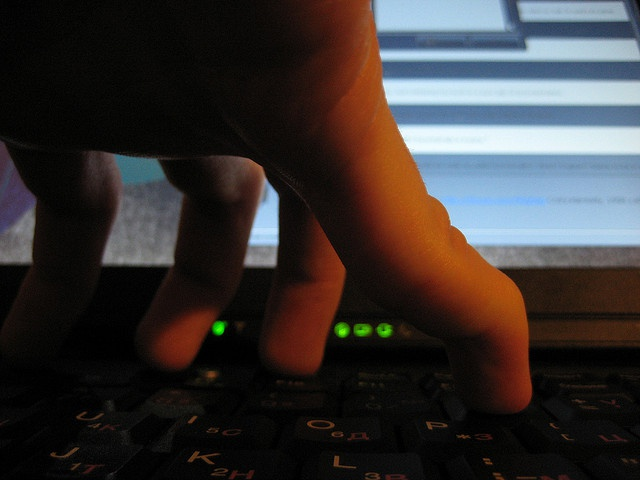Describe the objects in this image and their specific colors. I can see people in black, maroon, and brown tones and keyboard in black and maroon tones in this image. 